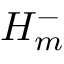Convert formula to latex. <formula><loc_0><loc_0><loc_500><loc_500>H _ { m } ^ { - }</formula> 